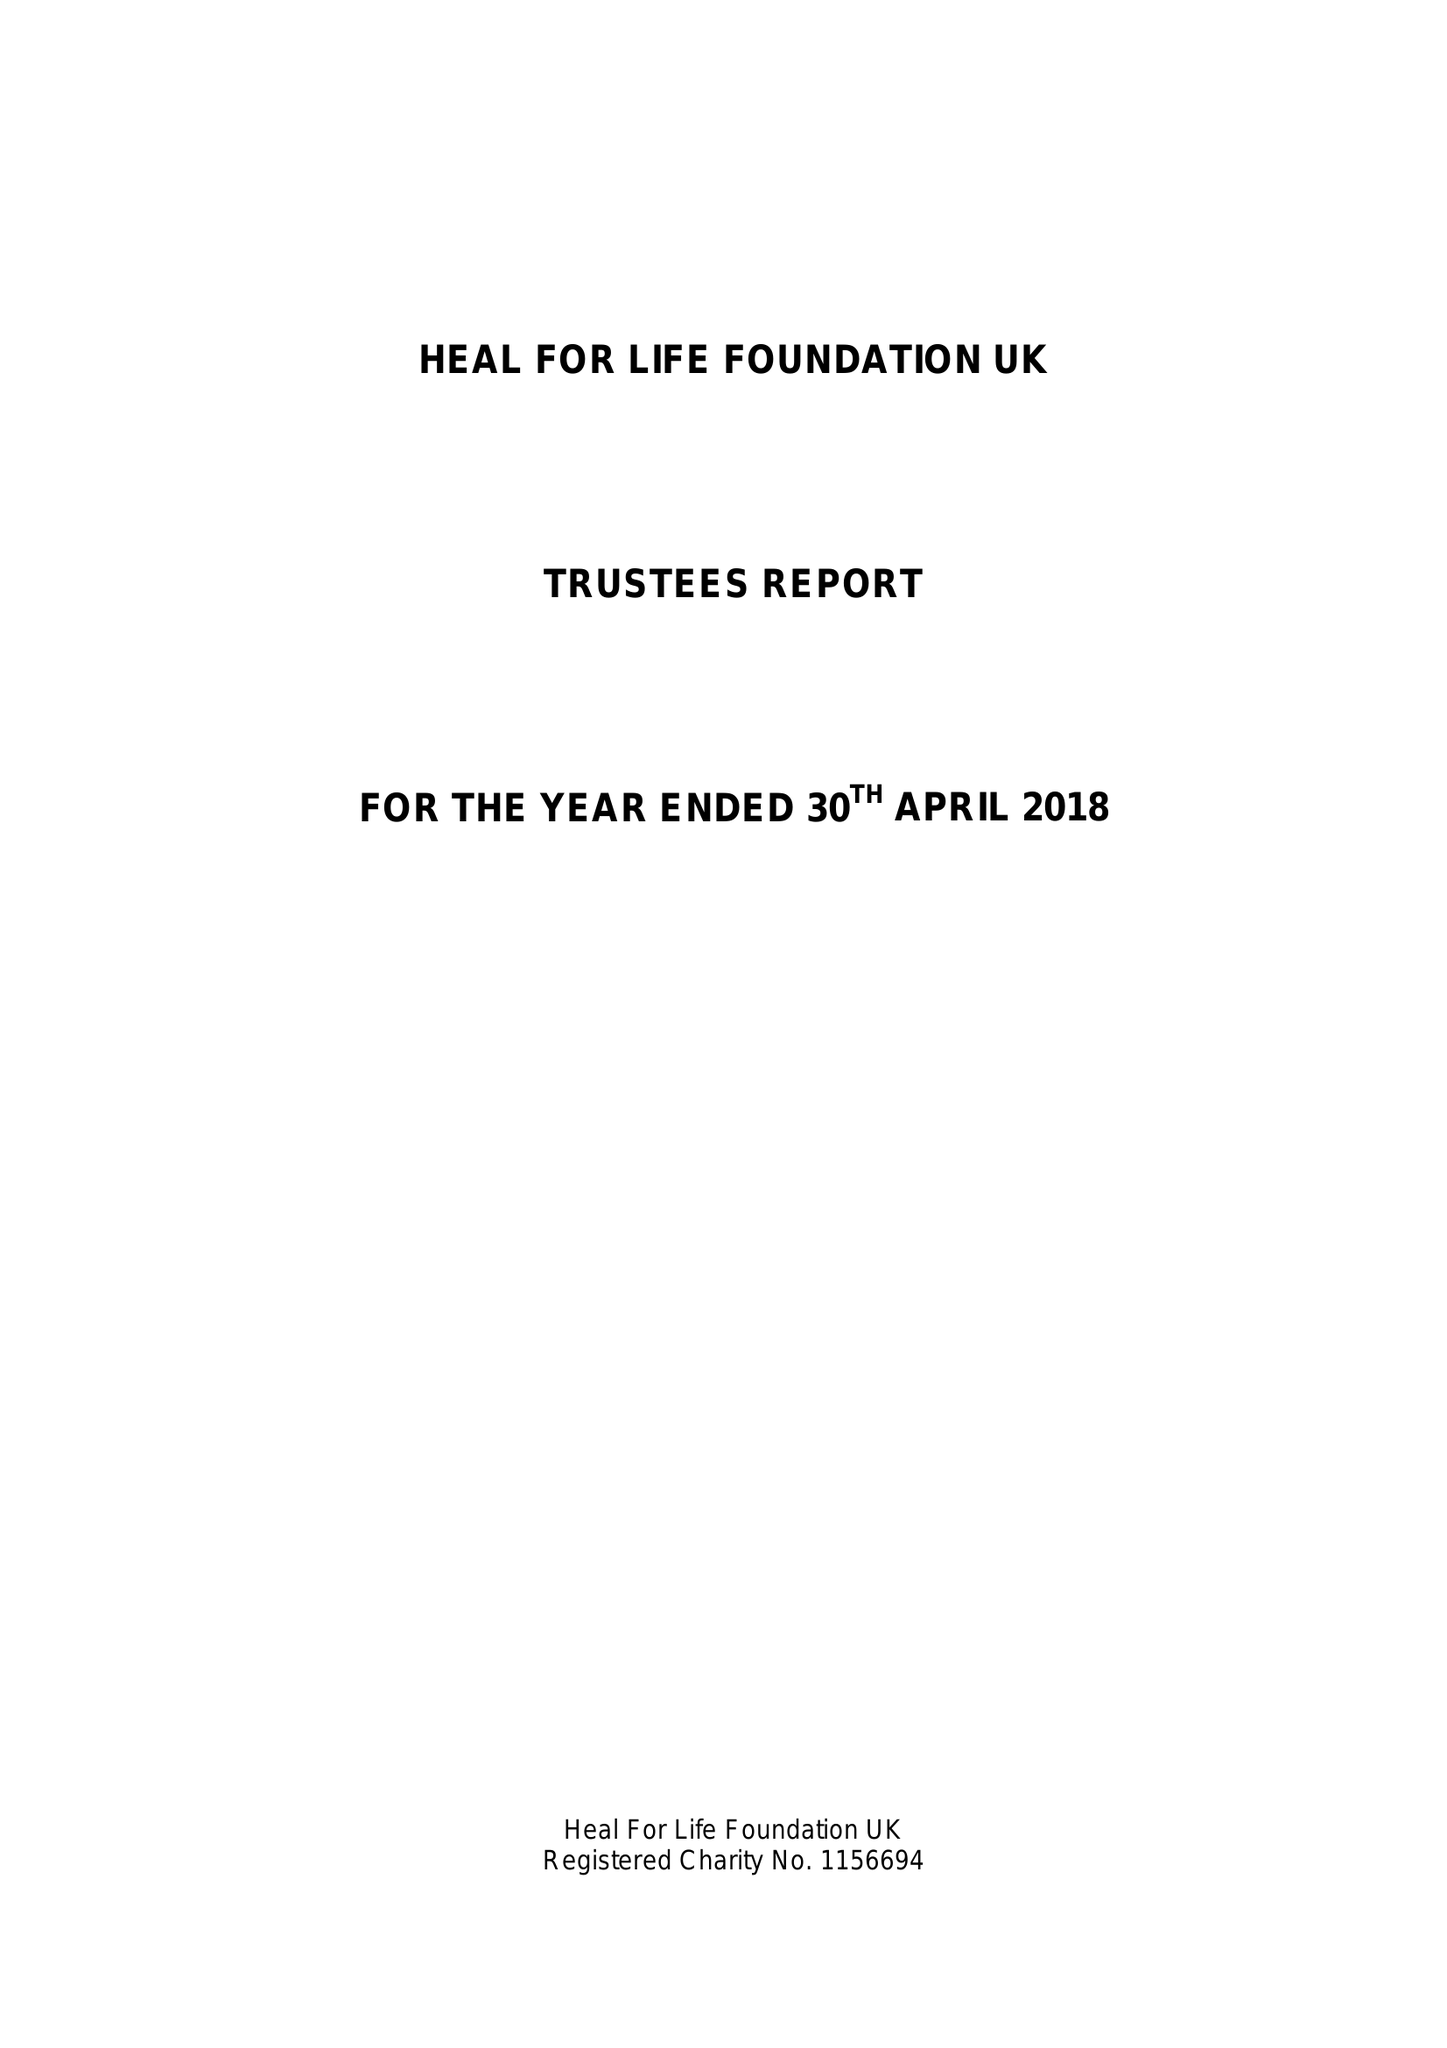What is the value for the address__postcode?
Answer the question using a single word or phrase. TN25 5BJ 